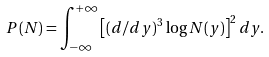Convert formula to latex. <formula><loc_0><loc_0><loc_500><loc_500>P ( N ) = \int _ { - \infty } ^ { + \infty } \left [ ( d / d y ) ^ { 3 } \log N ( y ) \right ] ^ { 2 } d y .</formula> 